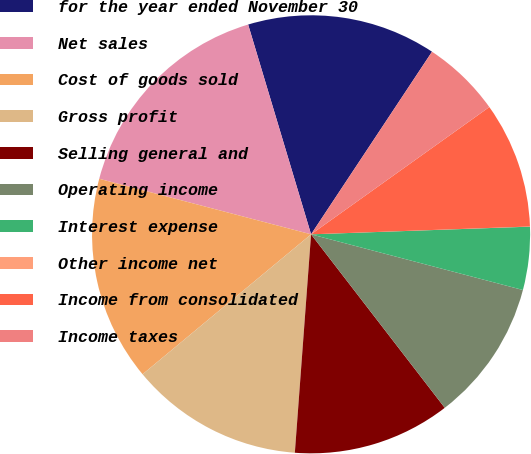Convert chart. <chart><loc_0><loc_0><loc_500><loc_500><pie_chart><fcel>for the year ended November 30<fcel>Net sales<fcel>Cost of goods sold<fcel>Gross profit<fcel>Selling general and<fcel>Operating income<fcel>Interest expense<fcel>Other income net<fcel>Income from consolidated<fcel>Income taxes<nl><fcel>13.95%<fcel>16.28%<fcel>15.11%<fcel>12.79%<fcel>11.63%<fcel>10.46%<fcel>4.65%<fcel>0.01%<fcel>9.3%<fcel>5.82%<nl></chart> 